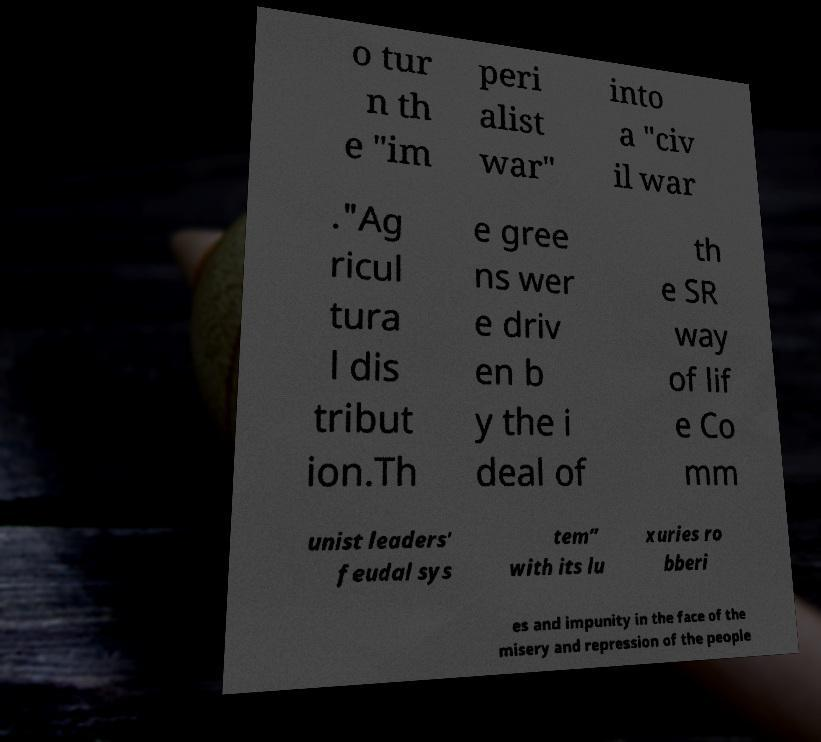Could you extract and type out the text from this image? o tur n th e "im peri alist war" into a "civ il war ."Ag ricul tura l dis tribut ion.Th e gree ns wer e driv en b y the i deal of th e SR way of lif e Co mm unist leaders' feudal sys tem” with its lu xuries ro bberi es and impunity in the face of the misery and repression of the people 